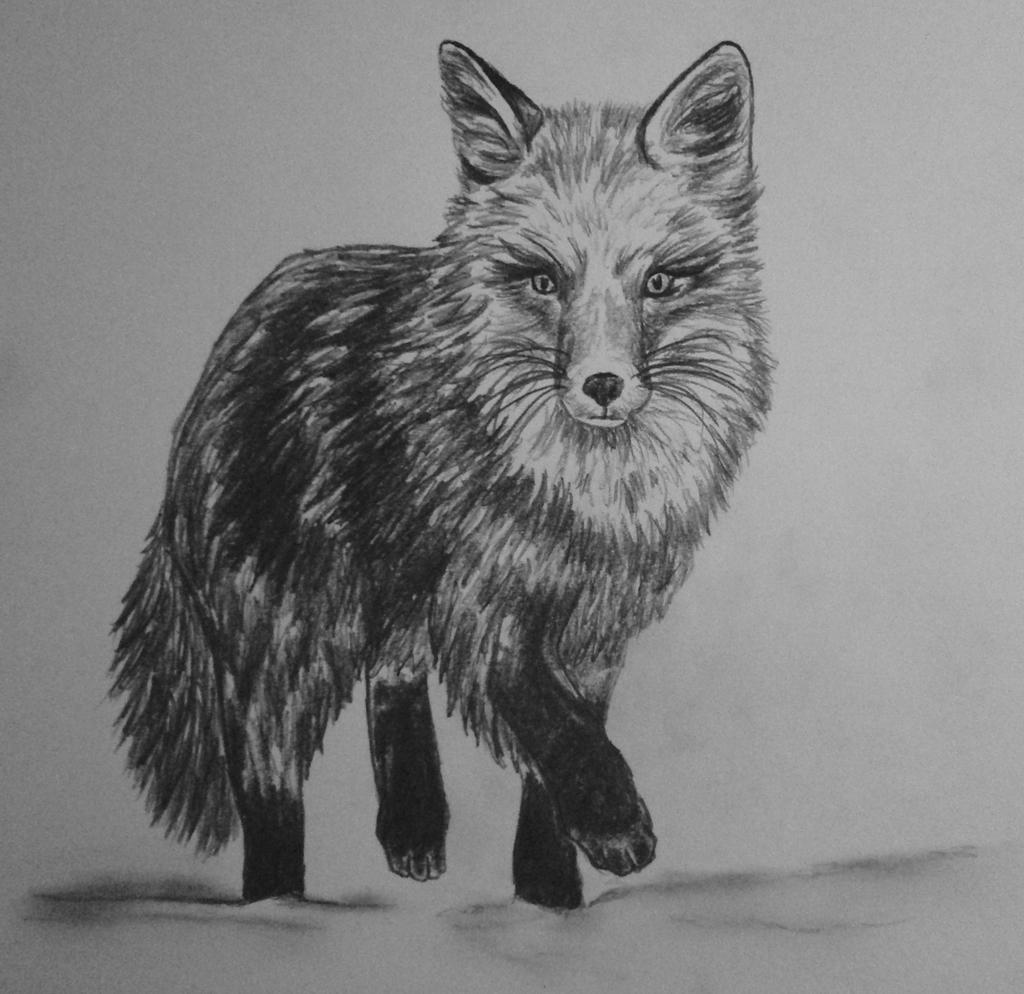What is depicted in the image? The image contains a sketch of an animal. What type of animal does the sketch resemble? The animal resembles a wolf. What is the color scheme of the image? The image is black and white. How many pancakes are stacked on the plate in the image? There are no pancakes present in the image; it contains a sketch of a wolf. What word is written on the animal's forehead in the image? There are no words written on the animal's forehead in the image; it is a sketch of a wolf without any text. 